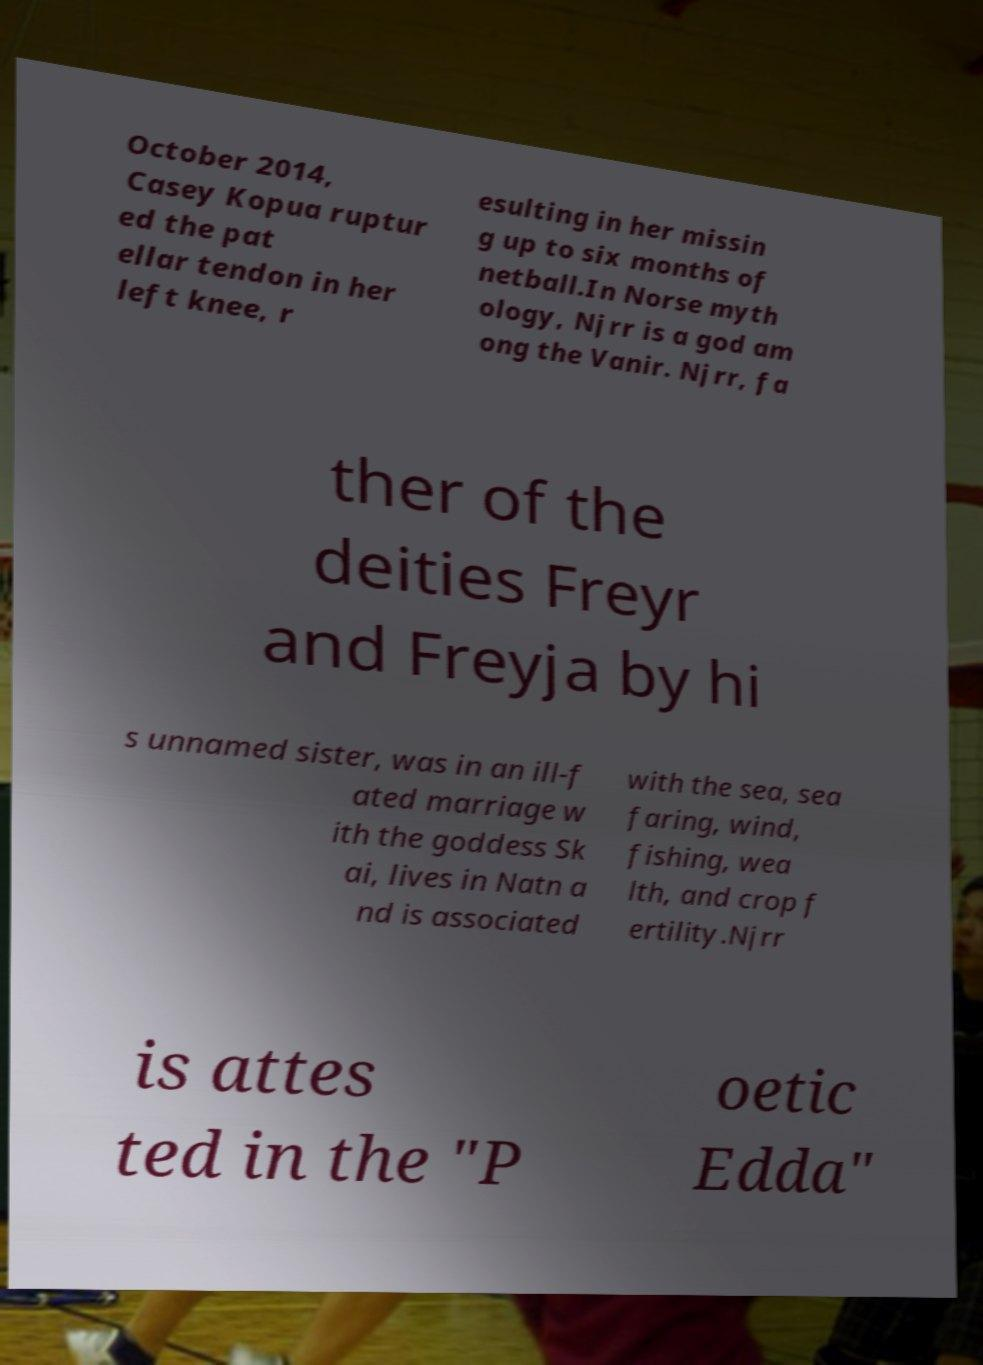Please identify and transcribe the text found in this image. October 2014, Casey Kopua ruptur ed the pat ellar tendon in her left knee, r esulting in her missin g up to six months of netball.In Norse myth ology, Njrr is a god am ong the Vanir. Njrr, fa ther of the deities Freyr and Freyja by hi s unnamed sister, was in an ill-f ated marriage w ith the goddess Sk ai, lives in Natn a nd is associated with the sea, sea faring, wind, fishing, wea lth, and crop f ertility.Njrr is attes ted in the "P oetic Edda" 